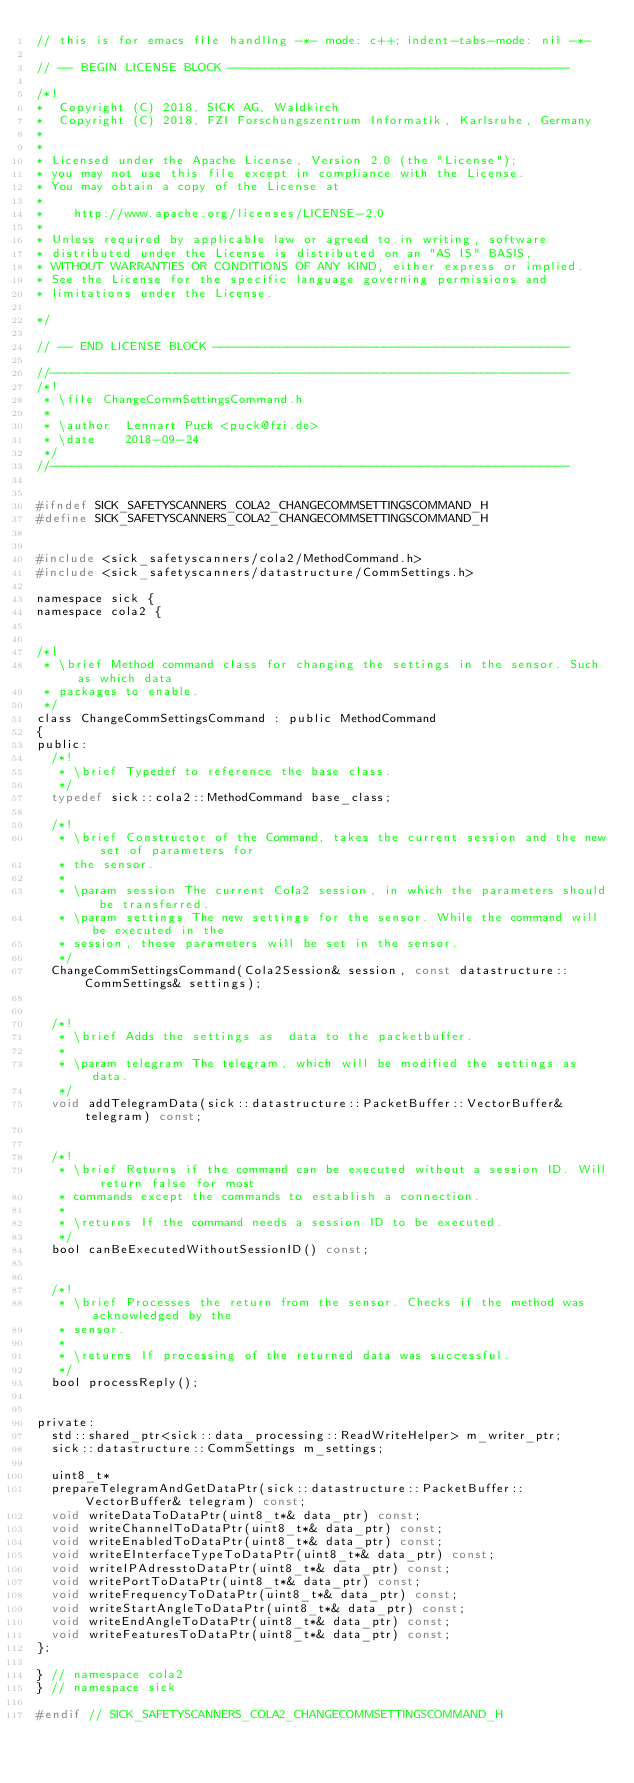<code> <loc_0><loc_0><loc_500><loc_500><_C_>// this is for emacs file handling -*- mode: c++; indent-tabs-mode: nil -*-

// -- BEGIN LICENSE BLOCK ----------------------------------------------

/*!
*  Copyright (C) 2018, SICK AG, Waldkirch
*  Copyright (C) 2018, FZI Forschungszentrum Informatik, Karlsruhe, Germany
*
*
* Licensed under the Apache License, Version 2.0 (the "License");
* you may not use this file except in compliance with the License.
* You may obtain a copy of the License at
*
*    http://www.apache.org/licenses/LICENSE-2.0
*
* Unless required by applicable law or agreed to in writing, software
* distributed under the License is distributed on an "AS IS" BASIS,
* WITHOUT WARRANTIES OR CONDITIONS OF ANY KIND, either express or implied.
* See the License for the specific language governing permissions and
* limitations under the License.

*/

// -- END LICENSE BLOCK ------------------------------------------------

//----------------------------------------------------------------------
/*!
 * \file ChangeCommSettingsCommand.h
 *
 * \author  Lennart Puck <puck@fzi.de>
 * \date    2018-09-24
 */
//----------------------------------------------------------------------


#ifndef SICK_SAFETYSCANNERS_COLA2_CHANGECOMMSETTINGSCOMMAND_H
#define SICK_SAFETYSCANNERS_COLA2_CHANGECOMMSETTINGSCOMMAND_H


#include <sick_safetyscanners/cola2/MethodCommand.h>
#include <sick_safetyscanners/datastructure/CommSettings.h>

namespace sick {
namespace cola2 {


/*!
 * \brief Method command class for changing the settings in the sensor. Such as which data
 * packages to enable.
 */
class ChangeCommSettingsCommand : public MethodCommand
{
public:
  /*!
   * \brief Typedef to reference the base class.
   */
  typedef sick::cola2::MethodCommand base_class;

  /*!
   * \brief Constructor of the Command, takes the current session and the new set of parameters for
   * the sensor.
   *
   * \param session The current Cola2 session, in which the parameters should be transferred.
   * \param settings The new settings for the sensor. While the command will be executed in the
   * session, these parameters will be set in the sensor.
   */
  ChangeCommSettingsCommand(Cola2Session& session, const datastructure::CommSettings& settings);


  /*!
   * \brief Adds the settings as  data to the packetbuffer.
   *
   * \param telegram The telegram, which will be modified the settings as data.
   */
  void addTelegramData(sick::datastructure::PacketBuffer::VectorBuffer& telegram) const;


  /*!
   * \brief Returns if the command can be executed without a session ID. Will return false for most
   * commands except the commands to establish a connection.
   *
   * \returns If the command needs a session ID to be executed.
   */
  bool canBeExecutedWithoutSessionID() const;


  /*!
   * \brief Processes the return from the sensor. Checks if the method was acknowledged by the
   * sensor.
   *
   * \returns If processing of the returned data was successful.
   */
  bool processReply();


private:
  std::shared_ptr<sick::data_processing::ReadWriteHelper> m_writer_ptr;
  sick::datastructure::CommSettings m_settings;

  uint8_t*
  prepareTelegramAndGetDataPtr(sick::datastructure::PacketBuffer::VectorBuffer& telegram) const;
  void writeDataToDataPtr(uint8_t*& data_ptr) const;
  void writeChannelToDataPtr(uint8_t*& data_ptr) const;
  void writeEnabledToDataPtr(uint8_t*& data_ptr) const;
  void writeEInterfaceTypeToDataPtr(uint8_t*& data_ptr) const;
  void writeIPAdresstoDataPtr(uint8_t*& data_ptr) const;
  void writePortToDataPtr(uint8_t*& data_ptr) const;
  void writeFrequencyToDataPtr(uint8_t*& data_ptr) const;
  void writeStartAngleToDataPtr(uint8_t*& data_ptr) const;
  void writeEndAngleToDataPtr(uint8_t*& data_ptr) const;
  void writeFeaturesToDataPtr(uint8_t*& data_ptr) const;
};

} // namespace cola2
} // namespace sick

#endif // SICK_SAFETYSCANNERS_COLA2_CHANGECOMMSETTINGSCOMMAND_H
</code> 